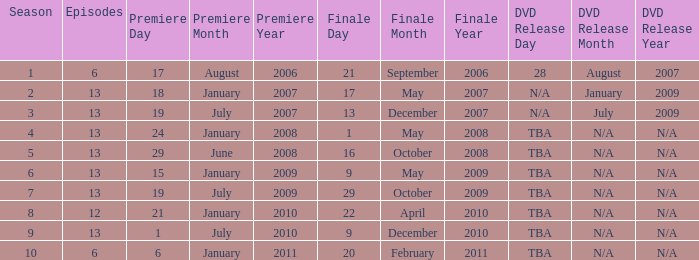Which season had fewer than 13 episodes and aired its season finale on February 20, 2011? 1.0. 